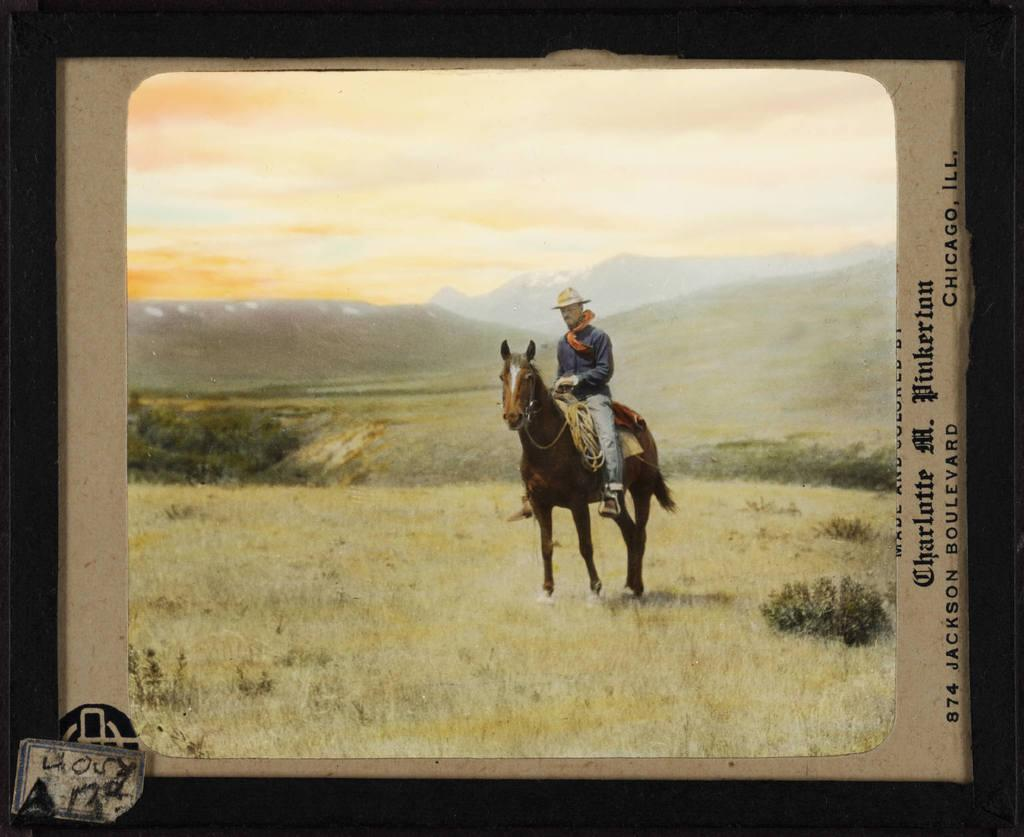What is the main subject of the image? There is a frame in the image, and within the frame, a man is riding a horse. Can you describe the setting of the image? There is grass visible behind the man and horse, and there are hills in the background of the image. How many tramps can be seen interacting with the cattle in the image? There are no tramps or cattle present in the image; it features a man riding a horse in a grassy area with hills in the background. 